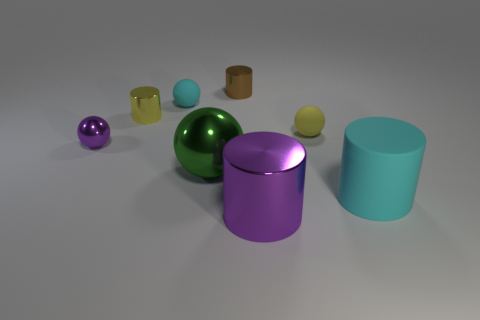What atmosphere or mood do the arrangement and colors of these objects convey? The objects are arranged in a pleasing, balanced manner with a mixture of cool and warm colors that create a calm and harmonious atmosphere. The simplicity and orderliness give the scene a serene, almost meditative mood. 